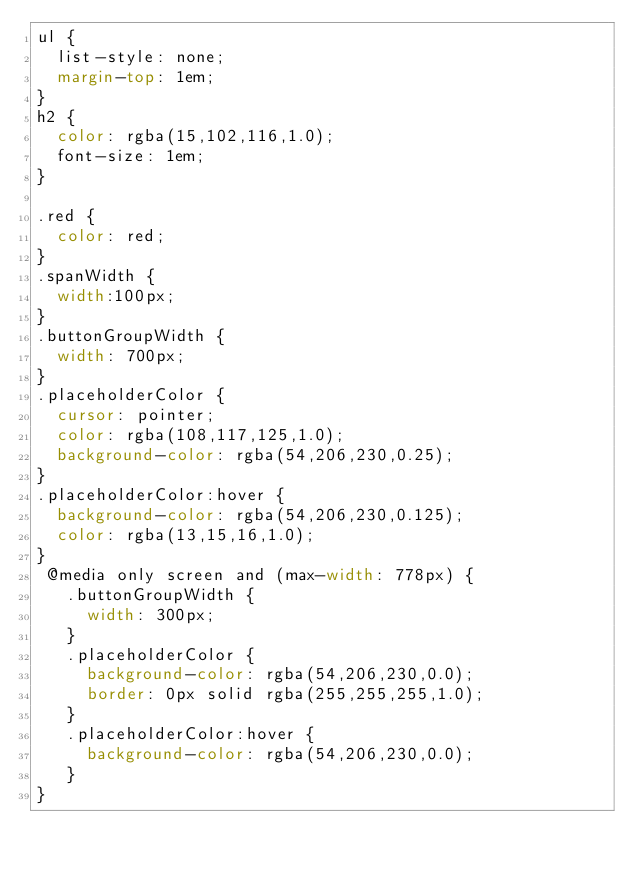<code> <loc_0><loc_0><loc_500><loc_500><_CSS_>ul {
  list-style: none;
  margin-top: 1em;
}
h2 {
  color: rgba(15,102,116,1.0);
  font-size: 1em;
}

.red {
  color: red;
}
.spanWidth {
  width:100px;
}
.buttonGroupWidth {
  width: 700px;
}
.placeholderColor {
  cursor: pointer;
  color: rgba(108,117,125,1.0);
  background-color: rgba(54,206,230,0.25);
}
.placeholderColor:hover {
  background-color: rgba(54,206,230,0.125);
  color: rgba(13,15,16,1.0);
}
 @media only screen and (max-width: 778px) {
   .buttonGroupWidth {
     width: 300px;
   }
   .placeholderColor {
     background-color: rgba(54,206,230,0.0);
     border: 0px solid rgba(255,255,255,1.0);
   }
   .placeholderColor:hover {
     background-color: rgba(54,206,230,0.0);
   }
}
</code> 